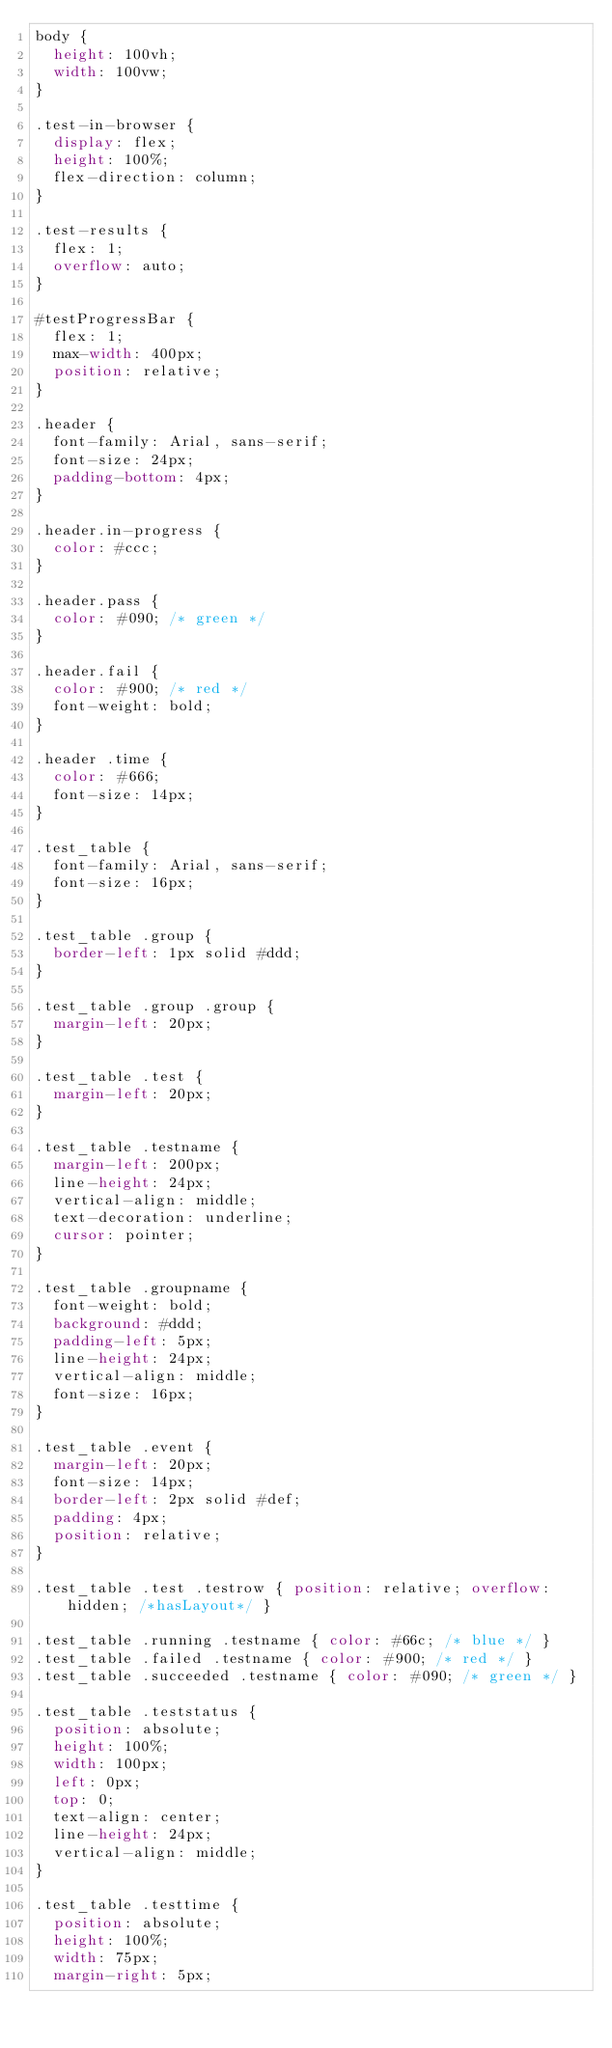<code> <loc_0><loc_0><loc_500><loc_500><_CSS_>body {
  height: 100vh;
  width: 100vw;
}

.test-in-browser {
  display: flex;
  height: 100%;
  flex-direction: column;
}

.test-results {
  flex: 1;
  overflow: auto;
}

#testProgressBar {
  flex: 1;
  max-width: 400px;
  position: relative;
}

.header {
  font-family: Arial, sans-serif;
  font-size: 24px;
  padding-bottom: 4px;
}

.header.in-progress {
  color: #ccc;
}

.header.pass {
  color: #090; /* green */
}

.header.fail {
  color: #900; /* red */
  font-weight: bold;
}

.header .time {
  color: #666;
  font-size: 14px;
}

.test_table {
  font-family: Arial, sans-serif;
  font-size: 16px;
}

.test_table .group {
  border-left: 1px solid #ddd;
}

.test_table .group .group {
  margin-left: 20px;
}

.test_table .test {
  margin-left: 20px;
}

.test_table .testname {
  margin-left: 200px;
  line-height: 24px;
  vertical-align: middle;
  text-decoration: underline;
  cursor: pointer;
}

.test_table .groupname {
  font-weight: bold;
  background: #ddd;
  padding-left: 5px;
  line-height: 24px;
  vertical-align: middle;
  font-size: 16px;
}

.test_table .event {
  margin-left: 20px;
  font-size: 14px;
  border-left: 2px solid #def;
  padding: 4px;
  position: relative;
}

.test_table .test .testrow { position: relative; overflow: hidden; /*hasLayout*/ }

.test_table .running .testname { color: #66c; /* blue */ }
.test_table .failed .testname { color: #900; /* red */ }
.test_table .succeeded .testname { color: #090; /* green */ }

.test_table .teststatus {
  position: absolute;
  height: 100%;
  width: 100px;
  left: 0px;
  top: 0;
  text-align: center;
  line-height: 24px;
  vertical-align: middle;
}

.test_table .testtime {
  position: absolute;
  height: 100%;
  width: 75px;
  margin-right: 5px;</code> 